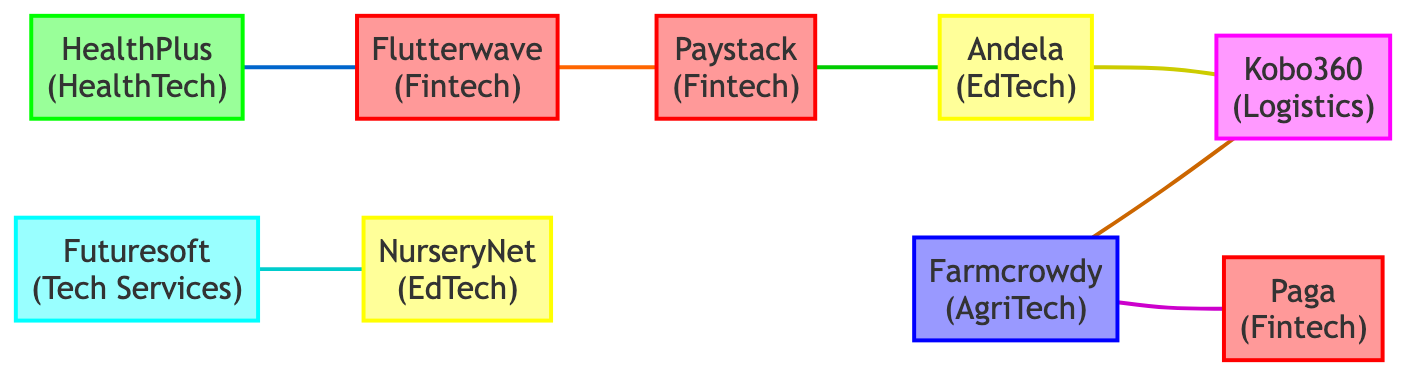What is the total number of nodes in the graph? By counting the entries under the "nodes" section, we find there are 9 distinct nodes that represent different startups.
Answer: 9 What type of business is Flutterwave? Looking at the node details for Flutterwave, it is labeled as a Fintech startup.
Answer: Fintech Which two startups are connected by a Logistics Partnership? Referring to the edges, Farmcrowdy and Kobo360 are noted as being connected through a Logistics Partnership.
Answer: Farmcrowdy and Kobo360 How many edges are there in total? By counting the entries under the "edges" section, we see that there are 7 connections established between the nodes.
Answer: 7 What type of integration did HealthPlus and Flutterwave undertake? The relationship specified between HealthPlus and Flutterwave is defined as "Service Integration," which implies a collaborative effort in integrating payment solutions.
Answer: Service Integration Who collaborated on talent sharing? The edge connecting Andela and Kobo360 indicates that these two startups engaged in a collaboration for talent sharing.
Answer: Andela and Kobo360 Which startup has the most partnerships listed? By reviewing the edges for each startup, we note that both Paystack and Farmcrowdy have 2 partnerships each, making them the most connected.
Answer: Paystack and Farmcrowdy What is the relationship between Paystack and Andela? The edge connecting these two indicates a "Mentorship" relationship focused on knowledge transfer in tech upskilling.
Answer: Mentorship Which startup offers IT consulting services? The relationship between Futuresoft and NurseryNet indicates that Futuresoft provided tech solutions and consultancy, hence offering IT consulting services.
Answer: Futuresoft 